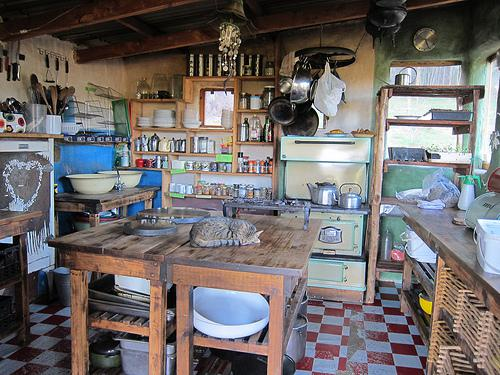Question: what is hanging above the stove?
Choices:
A. Forks.
B. Spoons.
C. Pots and pans.
D. Cups.
Answer with the letter. Answer: C Question: who is pictured?
Choices:
A. No one.
B. One person.
C. Two people.
D. Three people.
Answer with the letter. Answer: A Question: how many tables are pictured?
Choices:
A. 7.
B. 4.
C. 8.
D. 9.
Answer with the letter. Answer: B 